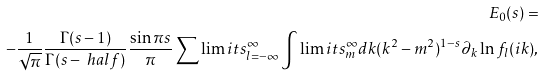Convert formula to latex. <formula><loc_0><loc_0><loc_500><loc_500>E _ { 0 } ( s ) = \\ - \frac { 1 } { \sqrt { \pi } } \frac { \Gamma ( s - 1 ) } { \Gamma ( s - \ h a l f ) } \frac { \sin \pi s } { \pi } \sum \lim i t s _ { l = - \infty } ^ { \infty } \int \lim i t s _ { m } ^ { \infty } d k ( k ^ { 2 } - m ^ { 2 } ) ^ { 1 - s } \partial _ { k } \ln f _ { l } ( i k ) ,</formula> 